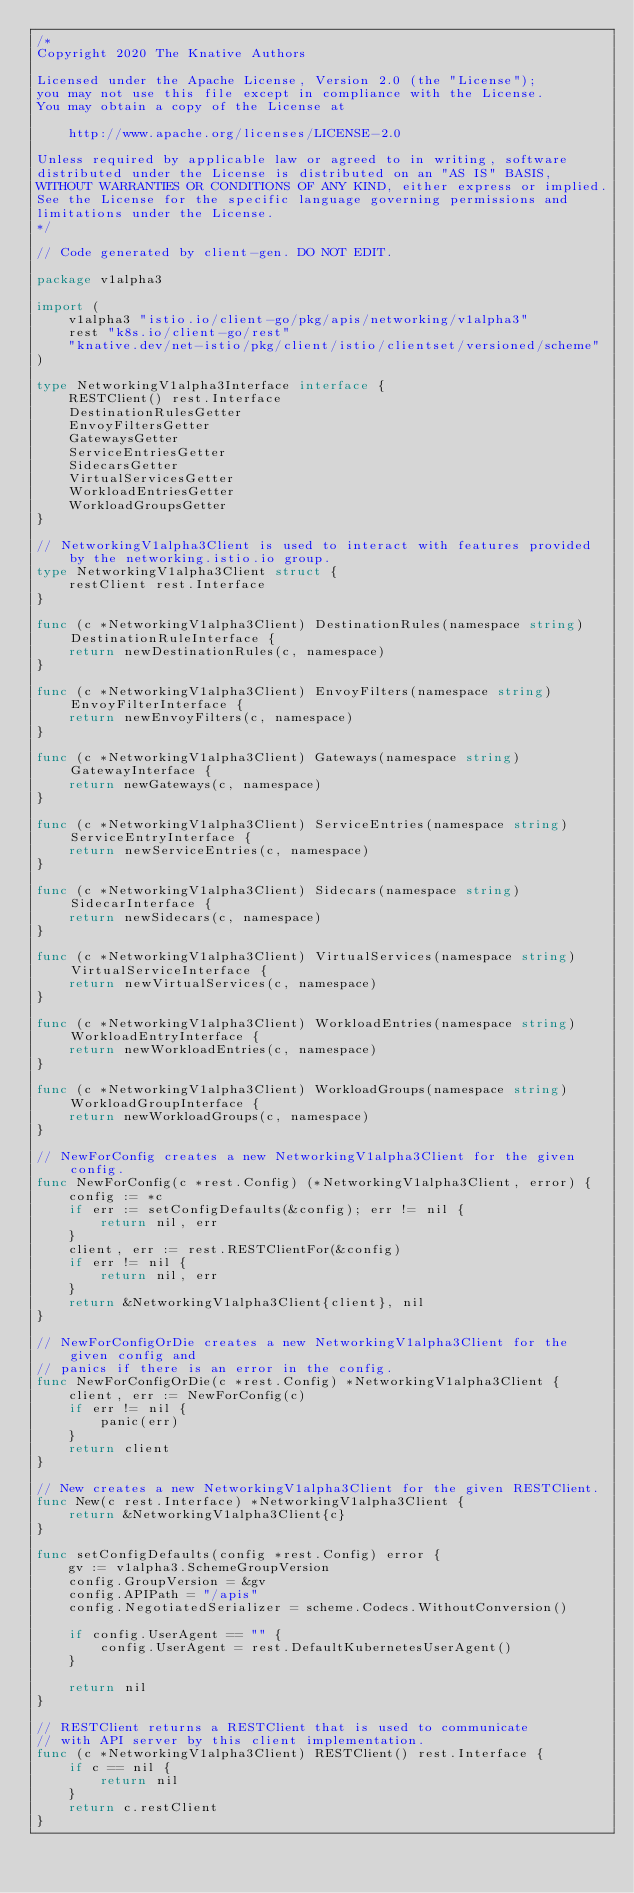Convert code to text. <code><loc_0><loc_0><loc_500><loc_500><_Go_>/*
Copyright 2020 The Knative Authors

Licensed under the Apache License, Version 2.0 (the "License");
you may not use this file except in compliance with the License.
You may obtain a copy of the License at

    http://www.apache.org/licenses/LICENSE-2.0

Unless required by applicable law or agreed to in writing, software
distributed under the License is distributed on an "AS IS" BASIS,
WITHOUT WARRANTIES OR CONDITIONS OF ANY KIND, either express or implied.
See the License for the specific language governing permissions and
limitations under the License.
*/

// Code generated by client-gen. DO NOT EDIT.

package v1alpha3

import (
	v1alpha3 "istio.io/client-go/pkg/apis/networking/v1alpha3"
	rest "k8s.io/client-go/rest"
	"knative.dev/net-istio/pkg/client/istio/clientset/versioned/scheme"
)

type NetworkingV1alpha3Interface interface {
	RESTClient() rest.Interface
	DestinationRulesGetter
	EnvoyFiltersGetter
	GatewaysGetter
	ServiceEntriesGetter
	SidecarsGetter
	VirtualServicesGetter
	WorkloadEntriesGetter
	WorkloadGroupsGetter
}

// NetworkingV1alpha3Client is used to interact with features provided by the networking.istio.io group.
type NetworkingV1alpha3Client struct {
	restClient rest.Interface
}

func (c *NetworkingV1alpha3Client) DestinationRules(namespace string) DestinationRuleInterface {
	return newDestinationRules(c, namespace)
}

func (c *NetworkingV1alpha3Client) EnvoyFilters(namespace string) EnvoyFilterInterface {
	return newEnvoyFilters(c, namespace)
}

func (c *NetworkingV1alpha3Client) Gateways(namespace string) GatewayInterface {
	return newGateways(c, namespace)
}

func (c *NetworkingV1alpha3Client) ServiceEntries(namespace string) ServiceEntryInterface {
	return newServiceEntries(c, namespace)
}

func (c *NetworkingV1alpha3Client) Sidecars(namespace string) SidecarInterface {
	return newSidecars(c, namespace)
}

func (c *NetworkingV1alpha3Client) VirtualServices(namespace string) VirtualServiceInterface {
	return newVirtualServices(c, namespace)
}

func (c *NetworkingV1alpha3Client) WorkloadEntries(namespace string) WorkloadEntryInterface {
	return newWorkloadEntries(c, namespace)
}

func (c *NetworkingV1alpha3Client) WorkloadGroups(namespace string) WorkloadGroupInterface {
	return newWorkloadGroups(c, namespace)
}

// NewForConfig creates a new NetworkingV1alpha3Client for the given config.
func NewForConfig(c *rest.Config) (*NetworkingV1alpha3Client, error) {
	config := *c
	if err := setConfigDefaults(&config); err != nil {
		return nil, err
	}
	client, err := rest.RESTClientFor(&config)
	if err != nil {
		return nil, err
	}
	return &NetworkingV1alpha3Client{client}, nil
}

// NewForConfigOrDie creates a new NetworkingV1alpha3Client for the given config and
// panics if there is an error in the config.
func NewForConfigOrDie(c *rest.Config) *NetworkingV1alpha3Client {
	client, err := NewForConfig(c)
	if err != nil {
		panic(err)
	}
	return client
}

// New creates a new NetworkingV1alpha3Client for the given RESTClient.
func New(c rest.Interface) *NetworkingV1alpha3Client {
	return &NetworkingV1alpha3Client{c}
}

func setConfigDefaults(config *rest.Config) error {
	gv := v1alpha3.SchemeGroupVersion
	config.GroupVersion = &gv
	config.APIPath = "/apis"
	config.NegotiatedSerializer = scheme.Codecs.WithoutConversion()

	if config.UserAgent == "" {
		config.UserAgent = rest.DefaultKubernetesUserAgent()
	}

	return nil
}

// RESTClient returns a RESTClient that is used to communicate
// with API server by this client implementation.
func (c *NetworkingV1alpha3Client) RESTClient() rest.Interface {
	if c == nil {
		return nil
	}
	return c.restClient
}
</code> 